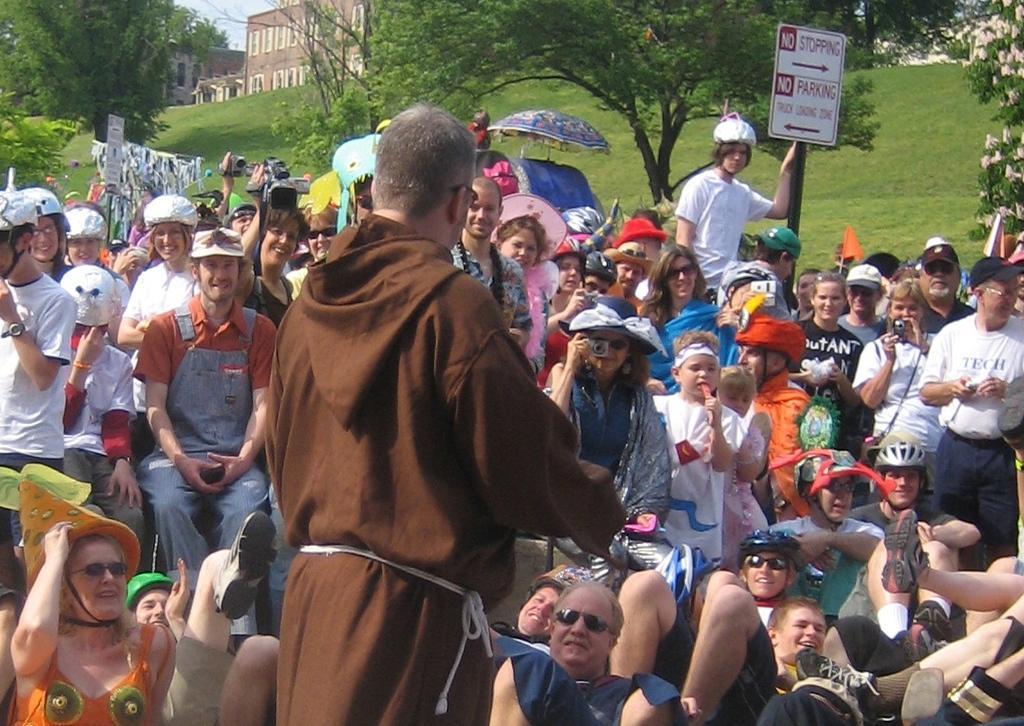Describe this image in one or two sentences. In this image we can see a man is standing and he is wearing brown color dress. In front of him so many people are sitting and standing and watching to him. Background of the image building, trees, grassy land and one sign board is present. 